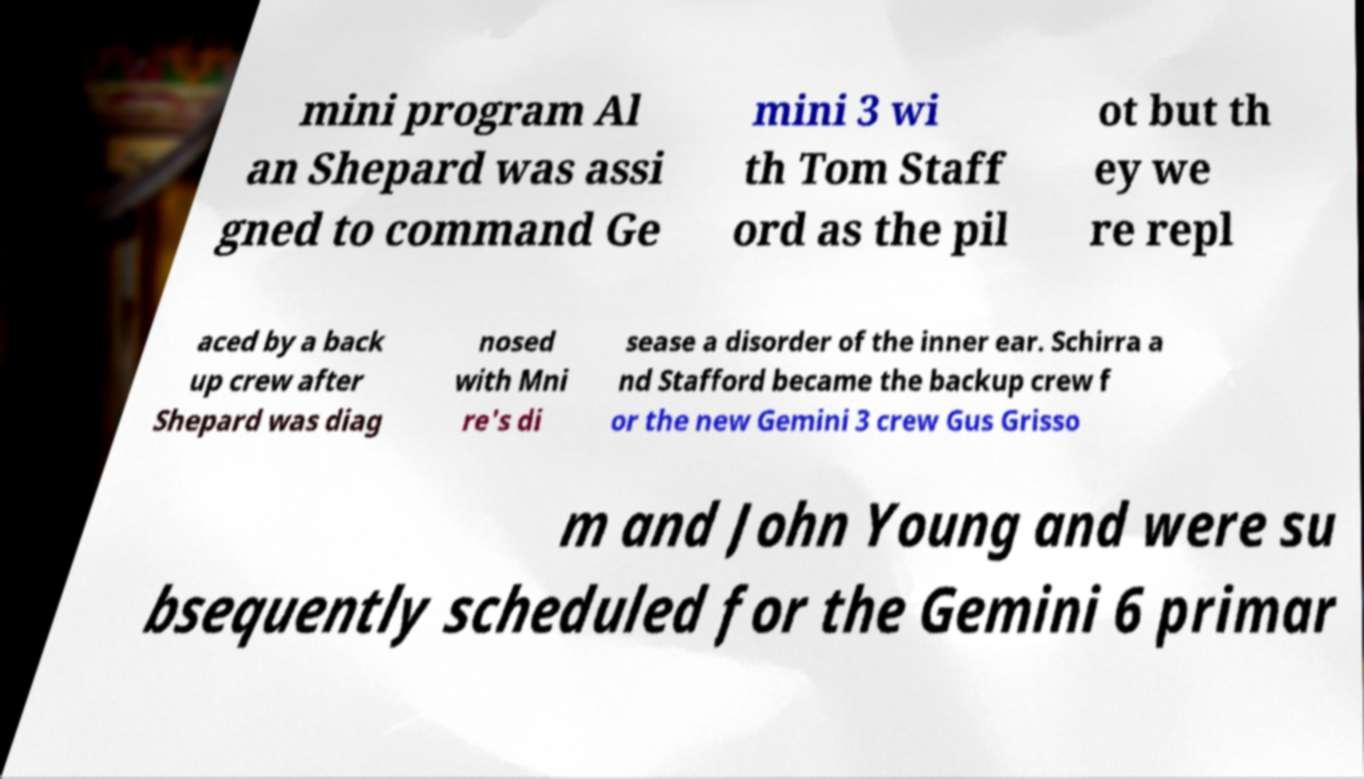Can you read and provide the text displayed in the image?This photo seems to have some interesting text. Can you extract and type it out for me? mini program Al an Shepard was assi gned to command Ge mini 3 wi th Tom Staff ord as the pil ot but th ey we re repl aced by a back up crew after Shepard was diag nosed with Mni re's di sease a disorder of the inner ear. Schirra a nd Stafford became the backup crew f or the new Gemini 3 crew Gus Grisso m and John Young and were su bsequently scheduled for the Gemini 6 primar 